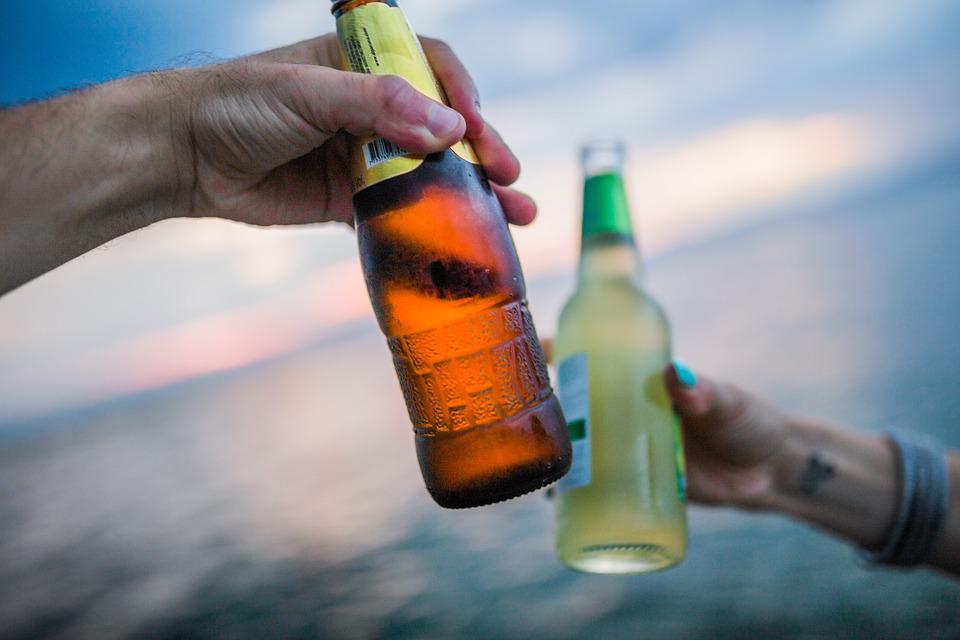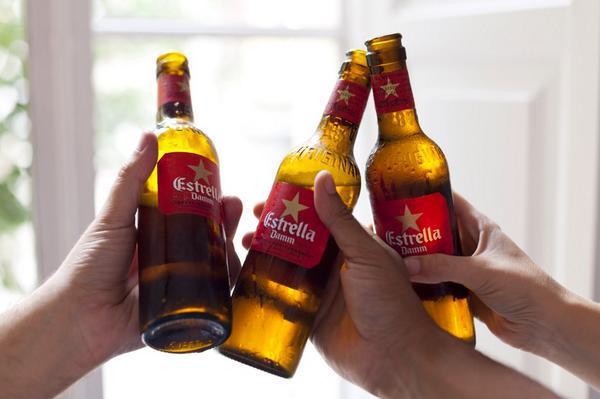The first image is the image on the left, the second image is the image on the right. Examine the images to the left and right. Is the description "There are exactly four bottles being toasted, two in each image." accurate? Answer yes or no. No. The first image is the image on the left, the second image is the image on the right. Given the left and right images, does the statement "Each image includes hands holding glass bottles that clink together at the bases of the bottles." hold true? Answer yes or no. Yes. 